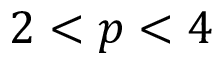Convert formula to latex. <formula><loc_0><loc_0><loc_500><loc_500>2 < p < 4</formula> 